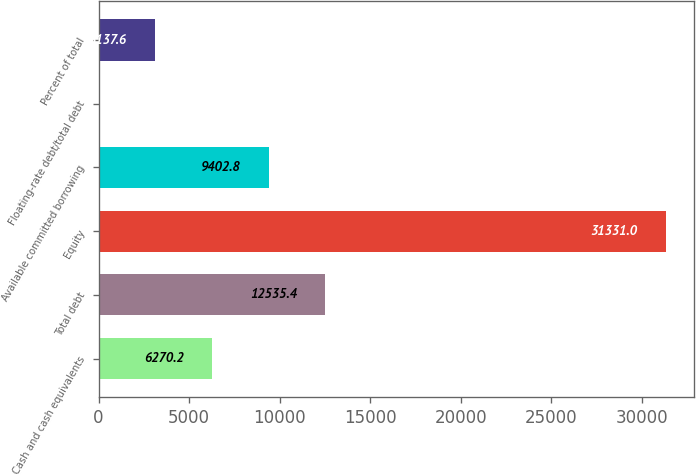Convert chart to OTSL. <chart><loc_0><loc_0><loc_500><loc_500><bar_chart><fcel>Cash and cash equivalents<fcel>Total debt<fcel>Equity<fcel>Available committed borrowing<fcel>Floating-rate debt/total debt<fcel>Percent of total<nl><fcel>6270.2<fcel>12535.4<fcel>31331<fcel>9402.8<fcel>5<fcel>3137.6<nl></chart> 